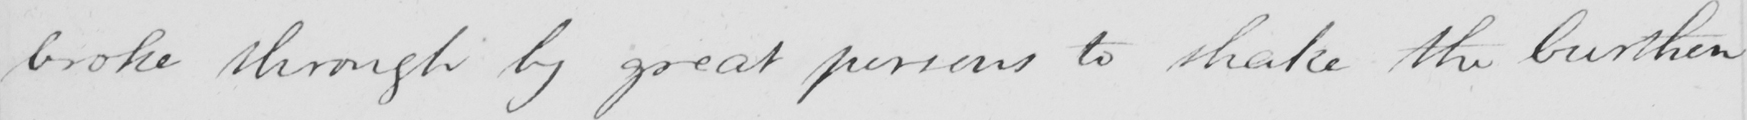Transcribe the text shown in this historical manuscript line. broke through by great persons to shake the burthen 